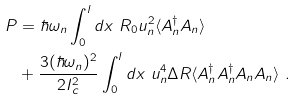Convert formula to latex. <formula><loc_0><loc_0><loc_500><loc_500>P & = \hbar { \omega } _ { n } \int _ { 0 } ^ { l } d x \ R _ { 0 } u _ { n } ^ { 2 } \langle A _ { n } ^ { \dagger } A _ { n } \rangle \\ & + \frac { 3 ( \hbar { \omega } _ { n } ) ^ { 2 } } { 2 I _ { c } ^ { 2 } } \int _ { 0 } ^ { l } d x \ u _ { n } ^ { 4 } \Delta R \langle A _ { n } ^ { \dagger } A _ { n } ^ { \dagger } A _ { n } A _ { n } \rangle \ .</formula> 